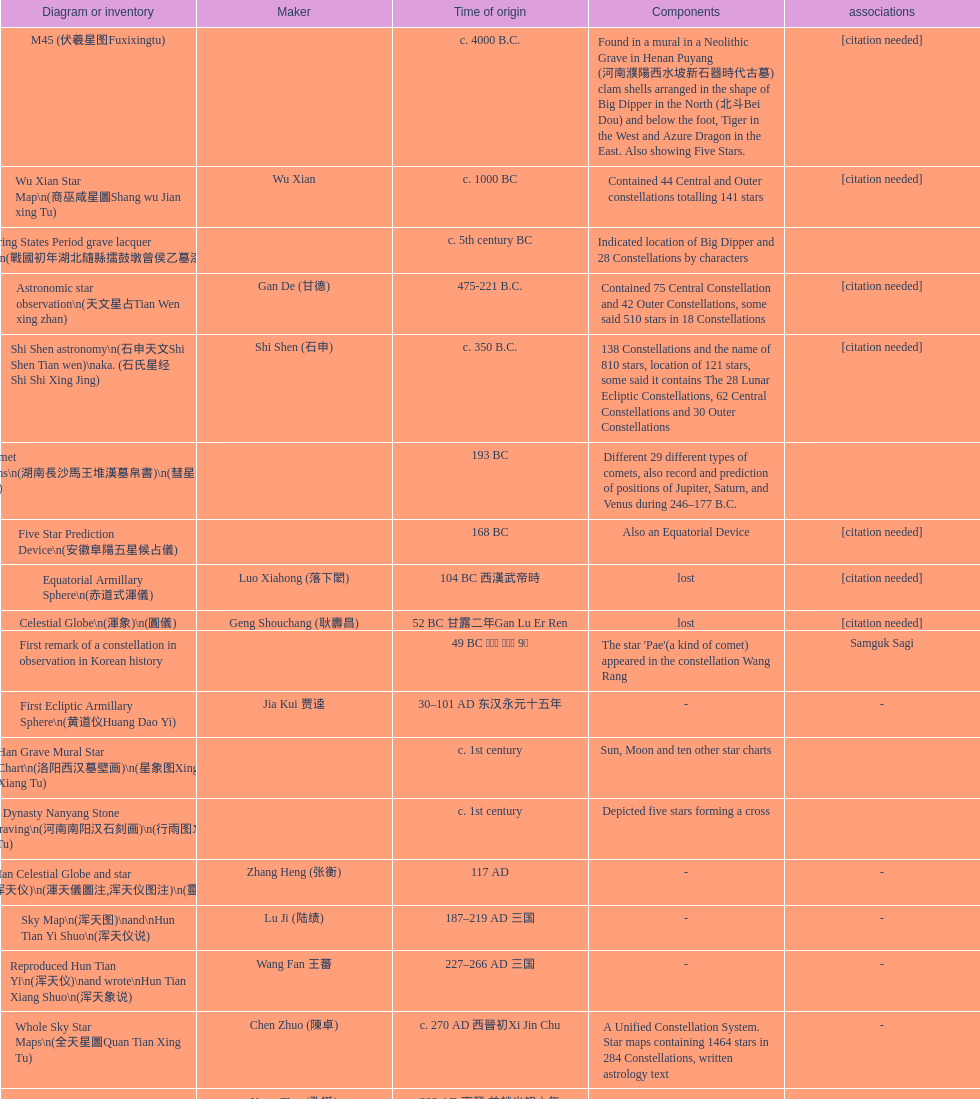Name three items created not long after the equatorial armillary sphere. Celestial Globe (渾象) (圓儀), First remark of a constellation in observation in Korean history, First Ecliptic Armillary Sphere (黄道仪Huang Dao Yi). 